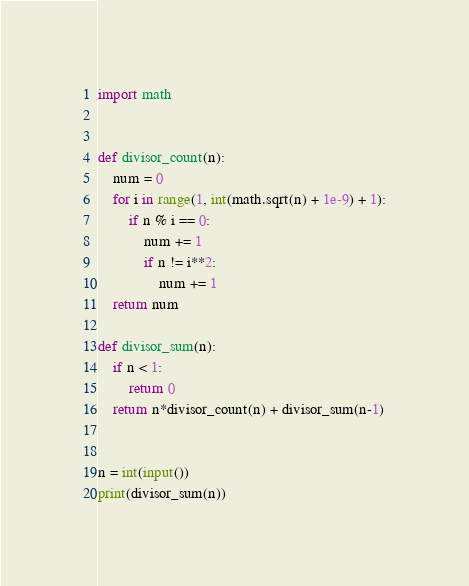Convert code to text. <code><loc_0><loc_0><loc_500><loc_500><_Python_>import math


def divisor_count(n):
    num = 0
    for i in range(1, int(math.sqrt(n) + 1e-9) + 1):
        if n % i == 0:
            num += 1
            if n != i**2:
                num += 1
    return num

def divisor_sum(n):
    if n < 1:
        return 0
    return n*divisor_count(n) + divisor_sum(n-1)


n = int(input())
print(divisor_sum(n))</code> 